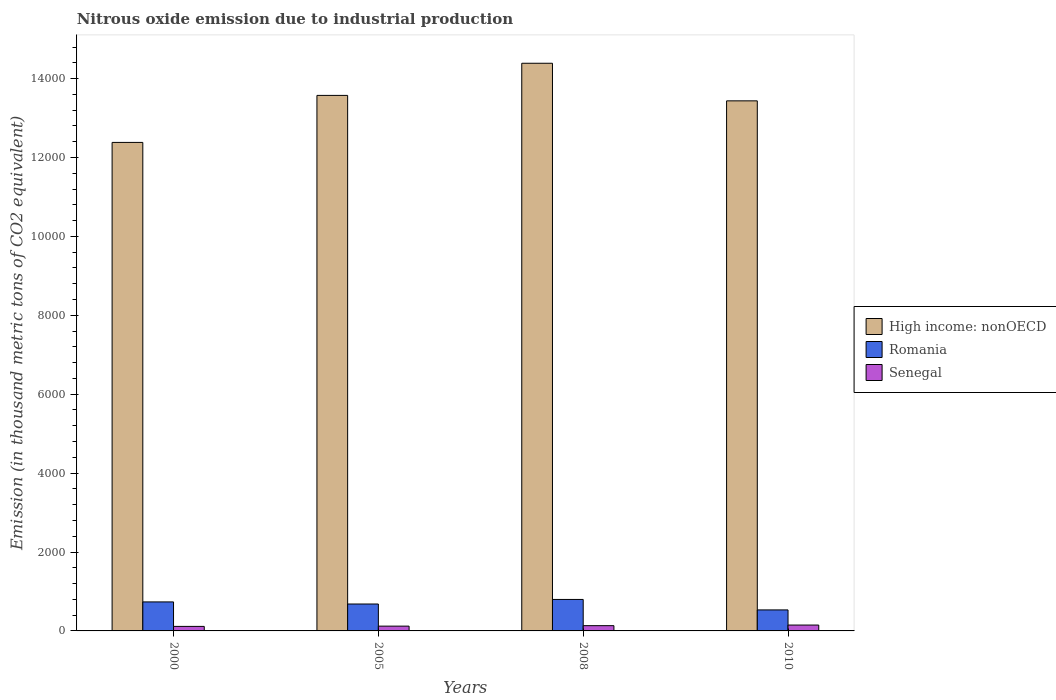Are the number of bars per tick equal to the number of legend labels?
Offer a very short reply. Yes. What is the amount of nitrous oxide emitted in Senegal in 2008?
Keep it short and to the point. 133.1. Across all years, what is the maximum amount of nitrous oxide emitted in Romania?
Make the answer very short. 798. Across all years, what is the minimum amount of nitrous oxide emitted in Senegal?
Give a very brief answer. 114.7. In which year was the amount of nitrous oxide emitted in High income: nonOECD minimum?
Give a very brief answer. 2000. What is the total amount of nitrous oxide emitted in High income: nonOECD in the graph?
Your response must be concise. 5.38e+04. What is the difference between the amount of nitrous oxide emitted in Romania in 2008 and that in 2010?
Make the answer very short. 265.6. What is the difference between the amount of nitrous oxide emitted in High income: nonOECD in 2008 and the amount of nitrous oxide emitted in Senegal in 2005?
Your response must be concise. 1.43e+04. What is the average amount of nitrous oxide emitted in Romania per year?
Provide a succinct answer. 687. In the year 2000, what is the difference between the amount of nitrous oxide emitted in Romania and amount of nitrous oxide emitted in Senegal?
Your answer should be compact. 620.6. What is the ratio of the amount of nitrous oxide emitted in Senegal in 2000 to that in 2008?
Keep it short and to the point. 0.86. Is the amount of nitrous oxide emitted in High income: nonOECD in 2008 less than that in 2010?
Give a very brief answer. No. Is the difference between the amount of nitrous oxide emitted in Romania in 2008 and 2010 greater than the difference between the amount of nitrous oxide emitted in Senegal in 2008 and 2010?
Provide a short and direct response. Yes. What is the difference between the highest and the second highest amount of nitrous oxide emitted in High income: nonOECD?
Give a very brief answer. 814.5. What is the difference between the highest and the lowest amount of nitrous oxide emitted in Romania?
Provide a succinct answer. 265.6. What does the 2nd bar from the left in 2010 represents?
Your answer should be very brief. Romania. What does the 2nd bar from the right in 2008 represents?
Give a very brief answer. Romania. Is it the case that in every year, the sum of the amount of nitrous oxide emitted in Senegal and amount of nitrous oxide emitted in Romania is greater than the amount of nitrous oxide emitted in High income: nonOECD?
Offer a very short reply. No. How many bars are there?
Your answer should be very brief. 12. What is the difference between two consecutive major ticks on the Y-axis?
Ensure brevity in your answer.  2000. Does the graph contain grids?
Offer a very short reply. No. Where does the legend appear in the graph?
Ensure brevity in your answer.  Center right. What is the title of the graph?
Offer a very short reply. Nitrous oxide emission due to industrial production. What is the label or title of the Y-axis?
Provide a short and direct response. Emission (in thousand metric tons of CO2 equivalent). What is the Emission (in thousand metric tons of CO2 equivalent) in High income: nonOECD in 2000?
Provide a succinct answer. 1.24e+04. What is the Emission (in thousand metric tons of CO2 equivalent) of Romania in 2000?
Your answer should be very brief. 735.3. What is the Emission (in thousand metric tons of CO2 equivalent) of Senegal in 2000?
Offer a very short reply. 114.7. What is the Emission (in thousand metric tons of CO2 equivalent) of High income: nonOECD in 2005?
Make the answer very short. 1.36e+04. What is the Emission (in thousand metric tons of CO2 equivalent) of Romania in 2005?
Your answer should be compact. 682.3. What is the Emission (in thousand metric tons of CO2 equivalent) of Senegal in 2005?
Ensure brevity in your answer.  121.2. What is the Emission (in thousand metric tons of CO2 equivalent) in High income: nonOECD in 2008?
Your answer should be compact. 1.44e+04. What is the Emission (in thousand metric tons of CO2 equivalent) of Romania in 2008?
Make the answer very short. 798. What is the Emission (in thousand metric tons of CO2 equivalent) of Senegal in 2008?
Make the answer very short. 133.1. What is the Emission (in thousand metric tons of CO2 equivalent) in High income: nonOECD in 2010?
Provide a succinct answer. 1.34e+04. What is the Emission (in thousand metric tons of CO2 equivalent) in Romania in 2010?
Offer a terse response. 532.4. What is the Emission (in thousand metric tons of CO2 equivalent) in Senegal in 2010?
Provide a succinct answer. 148.6. Across all years, what is the maximum Emission (in thousand metric tons of CO2 equivalent) of High income: nonOECD?
Your answer should be compact. 1.44e+04. Across all years, what is the maximum Emission (in thousand metric tons of CO2 equivalent) of Romania?
Give a very brief answer. 798. Across all years, what is the maximum Emission (in thousand metric tons of CO2 equivalent) in Senegal?
Your response must be concise. 148.6. Across all years, what is the minimum Emission (in thousand metric tons of CO2 equivalent) of High income: nonOECD?
Offer a very short reply. 1.24e+04. Across all years, what is the minimum Emission (in thousand metric tons of CO2 equivalent) in Romania?
Keep it short and to the point. 532.4. Across all years, what is the minimum Emission (in thousand metric tons of CO2 equivalent) in Senegal?
Provide a short and direct response. 114.7. What is the total Emission (in thousand metric tons of CO2 equivalent) in High income: nonOECD in the graph?
Ensure brevity in your answer.  5.38e+04. What is the total Emission (in thousand metric tons of CO2 equivalent) in Romania in the graph?
Your answer should be very brief. 2748. What is the total Emission (in thousand metric tons of CO2 equivalent) of Senegal in the graph?
Offer a terse response. 517.6. What is the difference between the Emission (in thousand metric tons of CO2 equivalent) of High income: nonOECD in 2000 and that in 2005?
Provide a short and direct response. -1191.8. What is the difference between the Emission (in thousand metric tons of CO2 equivalent) in High income: nonOECD in 2000 and that in 2008?
Offer a terse response. -2006.3. What is the difference between the Emission (in thousand metric tons of CO2 equivalent) in Romania in 2000 and that in 2008?
Make the answer very short. -62.7. What is the difference between the Emission (in thousand metric tons of CO2 equivalent) in Senegal in 2000 and that in 2008?
Your answer should be very brief. -18.4. What is the difference between the Emission (in thousand metric tons of CO2 equivalent) of High income: nonOECD in 2000 and that in 2010?
Your answer should be compact. -1053.6. What is the difference between the Emission (in thousand metric tons of CO2 equivalent) of Romania in 2000 and that in 2010?
Your response must be concise. 202.9. What is the difference between the Emission (in thousand metric tons of CO2 equivalent) of Senegal in 2000 and that in 2010?
Your response must be concise. -33.9. What is the difference between the Emission (in thousand metric tons of CO2 equivalent) in High income: nonOECD in 2005 and that in 2008?
Offer a terse response. -814.5. What is the difference between the Emission (in thousand metric tons of CO2 equivalent) in Romania in 2005 and that in 2008?
Make the answer very short. -115.7. What is the difference between the Emission (in thousand metric tons of CO2 equivalent) of Senegal in 2005 and that in 2008?
Your response must be concise. -11.9. What is the difference between the Emission (in thousand metric tons of CO2 equivalent) in High income: nonOECD in 2005 and that in 2010?
Provide a short and direct response. 138.2. What is the difference between the Emission (in thousand metric tons of CO2 equivalent) of Romania in 2005 and that in 2010?
Offer a terse response. 149.9. What is the difference between the Emission (in thousand metric tons of CO2 equivalent) in Senegal in 2005 and that in 2010?
Your answer should be compact. -27.4. What is the difference between the Emission (in thousand metric tons of CO2 equivalent) of High income: nonOECD in 2008 and that in 2010?
Offer a terse response. 952.7. What is the difference between the Emission (in thousand metric tons of CO2 equivalent) of Romania in 2008 and that in 2010?
Provide a succinct answer. 265.6. What is the difference between the Emission (in thousand metric tons of CO2 equivalent) of Senegal in 2008 and that in 2010?
Provide a short and direct response. -15.5. What is the difference between the Emission (in thousand metric tons of CO2 equivalent) in High income: nonOECD in 2000 and the Emission (in thousand metric tons of CO2 equivalent) in Romania in 2005?
Offer a very short reply. 1.17e+04. What is the difference between the Emission (in thousand metric tons of CO2 equivalent) of High income: nonOECD in 2000 and the Emission (in thousand metric tons of CO2 equivalent) of Senegal in 2005?
Keep it short and to the point. 1.23e+04. What is the difference between the Emission (in thousand metric tons of CO2 equivalent) of Romania in 2000 and the Emission (in thousand metric tons of CO2 equivalent) of Senegal in 2005?
Offer a terse response. 614.1. What is the difference between the Emission (in thousand metric tons of CO2 equivalent) in High income: nonOECD in 2000 and the Emission (in thousand metric tons of CO2 equivalent) in Romania in 2008?
Keep it short and to the point. 1.16e+04. What is the difference between the Emission (in thousand metric tons of CO2 equivalent) of High income: nonOECD in 2000 and the Emission (in thousand metric tons of CO2 equivalent) of Senegal in 2008?
Your answer should be compact. 1.22e+04. What is the difference between the Emission (in thousand metric tons of CO2 equivalent) in Romania in 2000 and the Emission (in thousand metric tons of CO2 equivalent) in Senegal in 2008?
Offer a very short reply. 602.2. What is the difference between the Emission (in thousand metric tons of CO2 equivalent) of High income: nonOECD in 2000 and the Emission (in thousand metric tons of CO2 equivalent) of Romania in 2010?
Your answer should be compact. 1.18e+04. What is the difference between the Emission (in thousand metric tons of CO2 equivalent) in High income: nonOECD in 2000 and the Emission (in thousand metric tons of CO2 equivalent) in Senegal in 2010?
Make the answer very short. 1.22e+04. What is the difference between the Emission (in thousand metric tons of CO2 equivalent) in Romania in 2000 and the Emission (in thousand metric tons of CO2 equivalent) in Senegal in 2010?
Offer a very short reply. 586.7. What is the difference between the Emission (in thousand metric tons of CO2 equivalent) in High income: nonOECD in 2005 and the Emission (in thousand metric tons of CO2 equivalent) in Romania in 2008?
Ensure brevity in your answer.  1.28e+04. What is the difference between the Emission (in thousand metric tons of CO2 equivalent) of High income: nonOECD in 2005 and the Emission (in thousand metric tons of CO2 equivalent) of Senegal in 2008?
Give a very brief answer. 1.34e+04. What is the difference between the Emission (in thousand metric tons of CO2 equivalent) of Romania in 2005 and the Emission (in thousand metric tons of CO2 equivalent) of Senegal in 2008?
Your answer should be very brief. 549.2. What is the difference between the Emission (in thousand metric tons of CO2 equivalent) in High income: nonOECD in 2005 and the Emission (in thousand metric tons of CO2 equivalent) in Romania in 2010?
Your response must be concise. 1.30e+04. What is the difference between the Emission (in thousand metric tons of CO2 equivalent) in High income: nonOECD in 2005 and the Emission (in thousand metric tons of CO2 equivalent) in Senegal in 2010?
Offer a very short reply. 1.34e+04. What is the difference between the Emission (in thousand metric tons of CO2 equivalent) in Romania in 2005 and the Emission (in thousand metric tons of CO2 equivalent) in Senegal in 2010?
Give a very brief answer. 533.7. What is the difference between the Emission (in thousand metric tons of CO2 equivalent) of High income: nonOECD in 2008 and the Emission (in thousand metric tons of CO2 equivalent) of Romania in 2010?
Your answer should be very brief. 1.39e+04. What is the difference between the Emission (in thousand metric tons of CO2 equivalent) of High income: nonOECD in 2008 and the Emission (in thousand metric tons of CO2 equivalent) of Senegal in 2010?
Make the answer very short. 1.42e+04. What is the difference between the Emission (in thousand metric tons of CO2 equivalent) of Romania in 2008 and the Emission (in thousand metric tons of CO2 equivalent) of Senegal in 2010?
Provide a short and direct response. 649.4. What is the average Emission (in thousand metric tons of CO2 equivalent) in High income: nonOECD per year?
Your response must be concise. 1.34e+04. What is the average Emission (in thousand metric tons of CO2 equivalent) in Romania per year?
Your response must be concise. 687. What is the average Emission (in thousand metric tons of CO2 equivalent) of Senegal per year?
Keep it short and to the point. 129.4. In the year 2000, what is the difference between the Emission (in thousand metric tons of CO2 equivalent) in High income: nonOECD and Emission (in thousand metric tons of CO2 equivalent) in Romania?
Your answer should be very brief. 1.16e+04. In the year 2000, what is the difference between the Emission (in thousand metric tons of CO2 equivalent) of High income: nonOECD and Emission (in thousand metric tons of CO2 equivalent) of Senegal?
Offer a very short reply. 1.23e+04. In the year 2000, what is the difference between the Emission (in thousand metric tons of CO2 equivalent) of Romania and Emission (in thousand metric tons of CO2 equivalent) of Senegal?
Your response must be concise. 620.6. In the year 2005, what is the difference between the Emission (in thousand metric tons of CO2 equivalent) in High income: nonOECD and Emission (in thousand metric tons of CO2 equivalent) in Romania?
Offer a very short reply. 1.29e+04. In the year 2005, what is the difference between the Emission (in thousand metric tons of CO2 equivalent) of High income: nonOECD and Emission (in thousand metric tons of CO2 equivalent) of Senegal?
Your response must be concise. 1.35e+04. In the year 2005, what is the difference between the Emission (in thousand metric tons of CO2 equivalent) in Romania and Emission (in thousand metric tons of CO2 equivalent) in Senegal?
Give a very brief answer. 561.1. In the year 2008, what is the difference between the Emission (in thousand metric tons of CO2 equivalent) in High income: nonOECD and Emission (in thousand metric tons of CO2 equivalent) in Romania?
Your answer should be compact. 1.36e+04. In the year 2008, what is the difference between the Emission (in thousand metric tons of CO2 equivalent) of High income: nonOECD and Emission (in thousand metric tons of CO2 equivalent) of Senegal?
Offer a terse response. 1.43e+04. In the year 2008, what is the difference between the Emission (in thousand metric tons of CO2 equivalent) in Romania and Emission (in thousand metric tons of CO2 equivalent) in Senegal?
Your answer should be compact. 664.9. In the year 2010, what is the difference between the Emission (in thousand metric tons of CO2 equivalent) of High income: nonOECD and Emission (in thousand metric tons of CO2 equivalent) of Romania?
Ensure brevity in your answer.  1.29e+04. In the year 2010, what is the difference between the Emission (in thousand metric tons of CO2 equivalent) in High income: nonOECD and Emission (in thousand metric tons of CO2 equivalent) in Senegal?
Provide a short and direct response. 1.33e+04. In the year 2010, what is the difference between the Emission (in thousand metric tons of CO2 equivalent) of Romania and Emission (in thousand metric tons of CO2 equivalent) of Senegal?
Provide a succinct answer. 383.8. What is the ratio of the Emission (in thousand metric tons of CO2 equivalent) in High income: nonOECD in 2000 to that in 2005?
Make the answer very short. 0.91. What is the ratio of the Emission (in thousand metric tons of CO2 equivalent) in Romania in 2000 to that in 2005?
Give a very brief answer. 1.08. What is the ratio of the Emission (in thousand metric tons of CO2 equivalent) of Senegal in 2000 to that in 2005?
Keep it short and to the point. 0.95. What is the ratio of the Emission (in thousand metric tons of CO2 equivalent) of High income: nonOECD in 2000 to that in 2008?
Provide a short and direct response. 0.86. What is the ratio of the Emission (in thousand metric tons of CO2 equivalent) of Romania in 2000 to that in 2008?
Make the answer very short. 0.92. What is the ratio of the Emission (in thousand metric tons of CO2 equivalent) of Senegal in 2000 to that in 2008?
Provide a succinct answer. 0.86. What is the ratio of the Emission (in thousand metric tons of CO2 equivalent) in High income: nonOECD in 2000 to that in 2010?
Keep it short and to the point. 0.92. What is the ratio of the Emission (in thousand metric tons of CO2 equivalent) in Romania in 2000 to that in 2010?
Offer a very short reply. 1.38. What is the ratio of the Emission (in thousand metric tons of CO2 equivalent) of Senegal in 2000 to that in 2010?
Your answer should be very brief. 0.77. What is the ratio of the Emission (in thousand metric tons of CO2 equivalent) in High income: nonOECD in 2005 to that in 2008?
Offer a very short reply. 0.94. What is the ratio of the Emission (in thousand metric tons of CO2 equivalent) of Romania in 2005 to that in 2008?
Offer a very short reply. 0.85. What is the ratio of the Emission (in thousand metric tons of CO2 equivalent) of Senegal in 2005 to that in 2008?
Your answer should be very brief. 0.91. What is the ratio of the Emission (in thousand metric tons of CO2 equivalent) of High income: nonOECD in 2005 to that in 2010?
Offer a terse response. 1.01. What is the ratio of the Emission (in thousand metric tons of CO2 equivalent) of Romania in 2005 to that in 2010?
Your response must be concise. 1.28. What is the ratio of the Emission (in thousand metric tons of CO2 equivalent) of Senegal in 2005 to that in 2010?
Offer a very short reply. 0.82. What is the ratio of the Emission (in thousand metric tons of CO2 equivalent) in High income: nonOECD in 2008 to that in 2010?
Your answer should be compact. 1.07. What is the ratio of the Emission (in thousand metric tons of CO2 equivalent) in Romania in 2008 to that in 2010?
Make the answer very short. 1.5. What is the ratio of the Emission (in thousand metric tons of CO2 equivalent) in Senegal in 2008 to that in 2010?
Offer a very short reply. 0.9. What is the difference between the highest and the second highest Emission (in thousand metric tons of CO2 equivalent) of High income: nonOECD?
Keep it short and to the point. 814.5. What is the difference between the highest and the second highest Emission (in thousand metric tons of CO2 equivalent) of Romania?
Make the answer very short. 62.7. What is the difference between the highest and the second highest Emission (in thousand metric tons of CO2 equivalent) of Senegal?
Provide a succinct answer. 15.5. What is the difference between the highest and the lowest Emission (in thousand metric tons of CO2 equivalent) of High income: nonOECD?
Offer a terse response. 2006.3. What is the difference between the highest and the lowest Emission (in thousand metric tons of CO2 equivalent) of Romania?
Offer a terse response. 265.6. What is the difference between the highest and the lowest Emission (in thousand metric tons of CO2 equivalent) in Senegal?
Offer a terse response. 33.9. 